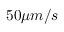Convert formula to latex. <formula><loc_0><loc_0><loc_500><loc_500>5 0 \mu m / s</formula> 